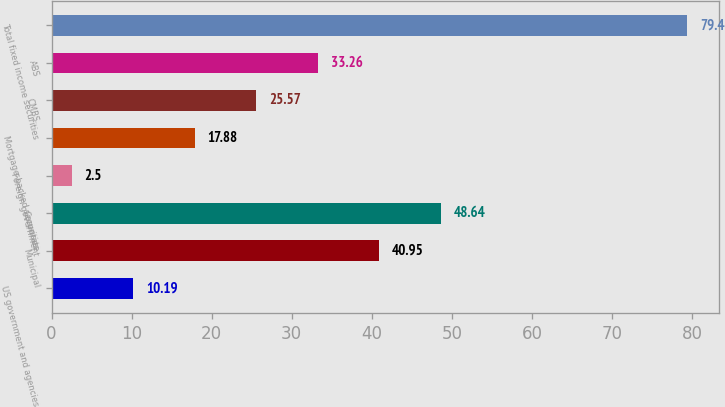Convert chart. <chart><loc_0><loc_0><loc_500><loc_500><bar_chart><fcel>US government and agencies<fcel>Municipal<fcel>Corporate<fcel>Foreign government<fcel>Mortgage-backed securities<fcel>CMBS<fcel>ABS<fcel>Total fixed income securities<nl><fcel>10.19<fcel>40.95<fcel>48.64<fcel>2.5<fcel>17.88<fcel>25.57<fcel>33.26<fcel>79.4<nl></chart> 